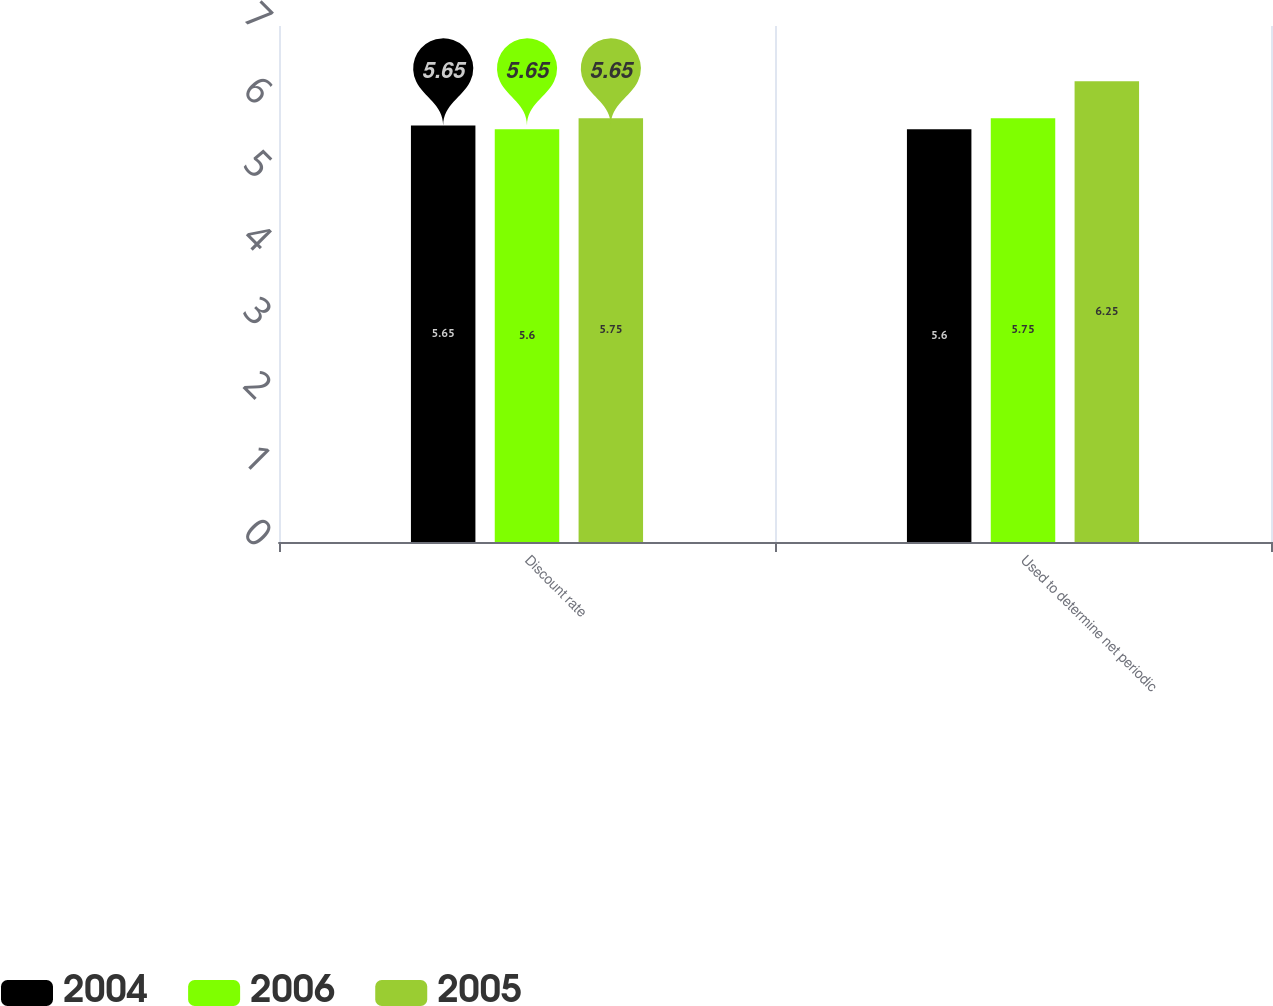Convert chart. <chart><loc_0><loc_0><loc_500><loc_500><stacked_bar_chart><ecel><fcel>Discount rate<fcel>Used to determine net periodic<nl><fcel>2004<fcel>5.65<fcel>5.6<nl><fcel>2006<fcel>5.6<fcel>5.75<nl><fcel>2005<fcel>5.75<fcel>6.25<nl></chart> 